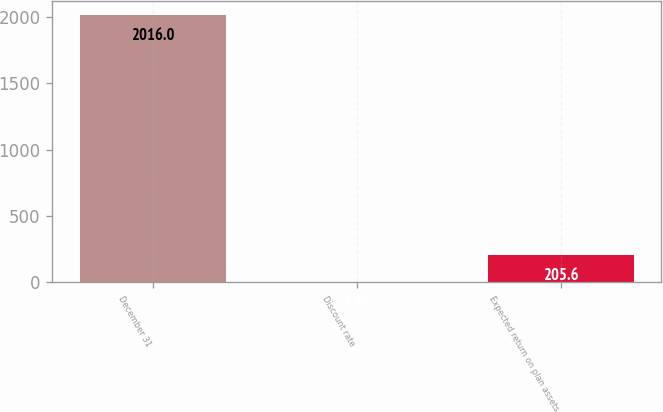Convert chart to OTSL. <chart><loc_0><loc_0><loc_500><loc_500><bar_chart><fcel>December 31<fcel>Discount rate<fcel>Expected return on plan assets<nl><fcel>2016<fcel>4.45<fcel>205.6<nl></chart> 